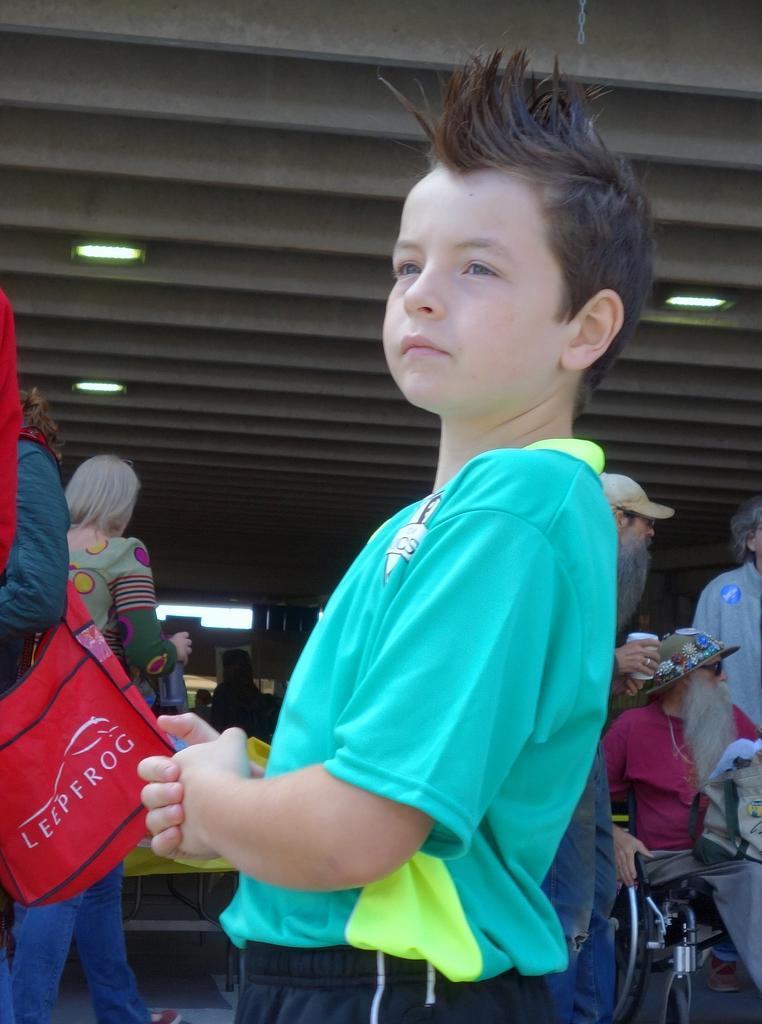In one or two sentences, can you explain what this image depicts? This image is taken indoors. At the top of the image there is a ceiling with a few lights. In the middle of the image a boy is standing. In the background a few people are walking. On the right side of the image a man is sitting on the wheelchair and two persons are standing. On the left side of the image two women are walking. 